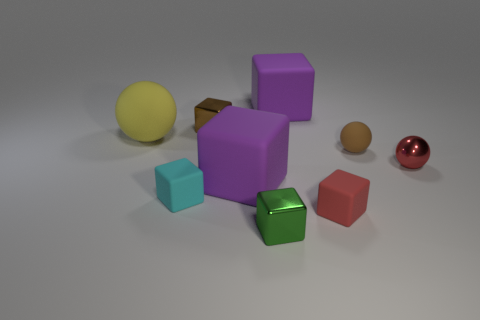What size is the purple matte cube that is on the left side of the thing that is in front of the red object that is in front of the cyan cube?
Your response must be concise. Large. Is the number of small green metallic cubes right of the tiny red metal sphere the same as the number of tiny cyan objects?
Offer a very short reply. No. Is there anything else that has the same shape as the small green metallic thing?
Ensure brevity in your answer.  Yes. There is a yellow rubber object; is its shape the same as the brown thing right of the small red block?
Offer a very short reply. Yes. What is the size of the red matte object that is the same shape as the tiny green shiny object?
Offer a very short reply. Small. How many other things are made of the same material as the cyan cube?
Ensure brevity in your answer.  5. What is the material of the big ball?
Make the answer very short. Rubber. There is a tiny metallic cube on the left side of the small green metallic thing; is its color the same as the small metallic thing that is in front of the tiny red metallic ball?
Give a very brief answer. No. Are there more brown cubes that are on the left side of the cyan block than purple matte blocks?
Your response must be concise. No. How many other objects are the same color as the small shiny sphere?
Your answer should be very brief. 1. 